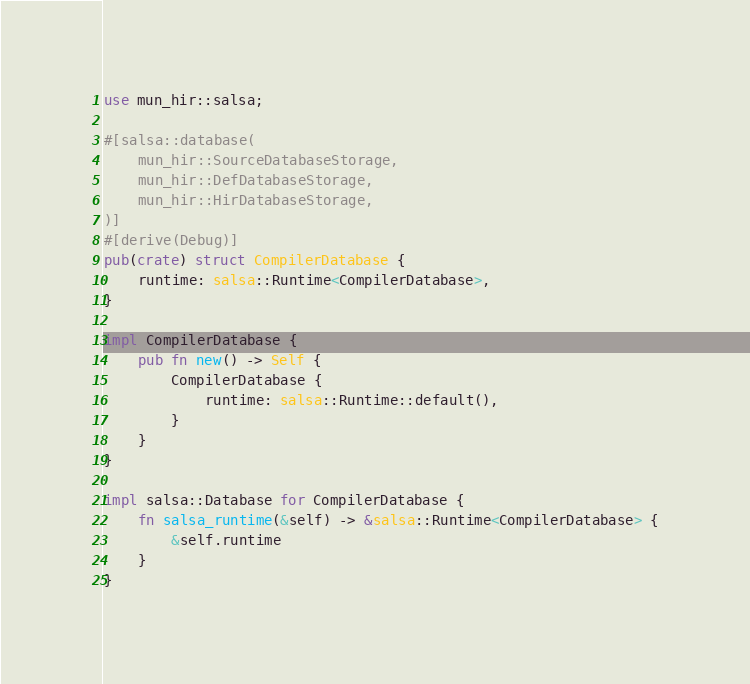<code> <loc_0><loc_0><loc_500><loc_500><_Rust_>use mun_hir::salsa;

#[salsa::database(
    mun_hir::SourceDatabaseStorage,
    mun_hir::DefDatabaseStorage,
    mun_hir::HirDatabaseStorage,
)]
#[derive(Debug)]
pub(crate) struct CompilerDatabase {
    runtime: salsa::Runtime<CompilerDatabase>,
}

impl CompilerDatabase {
    pub fn new() -> Self {
        CompilerDatabase {
            runtime: salsa::Runtime::default(),
        }
    }
}

impl salsa::Database for CompilerDatabase {
    fn salsa_runtime(&self) -> &salsa::Runtime<CompilerDatabase> {
        &self.runtime
    }
}
</code> 